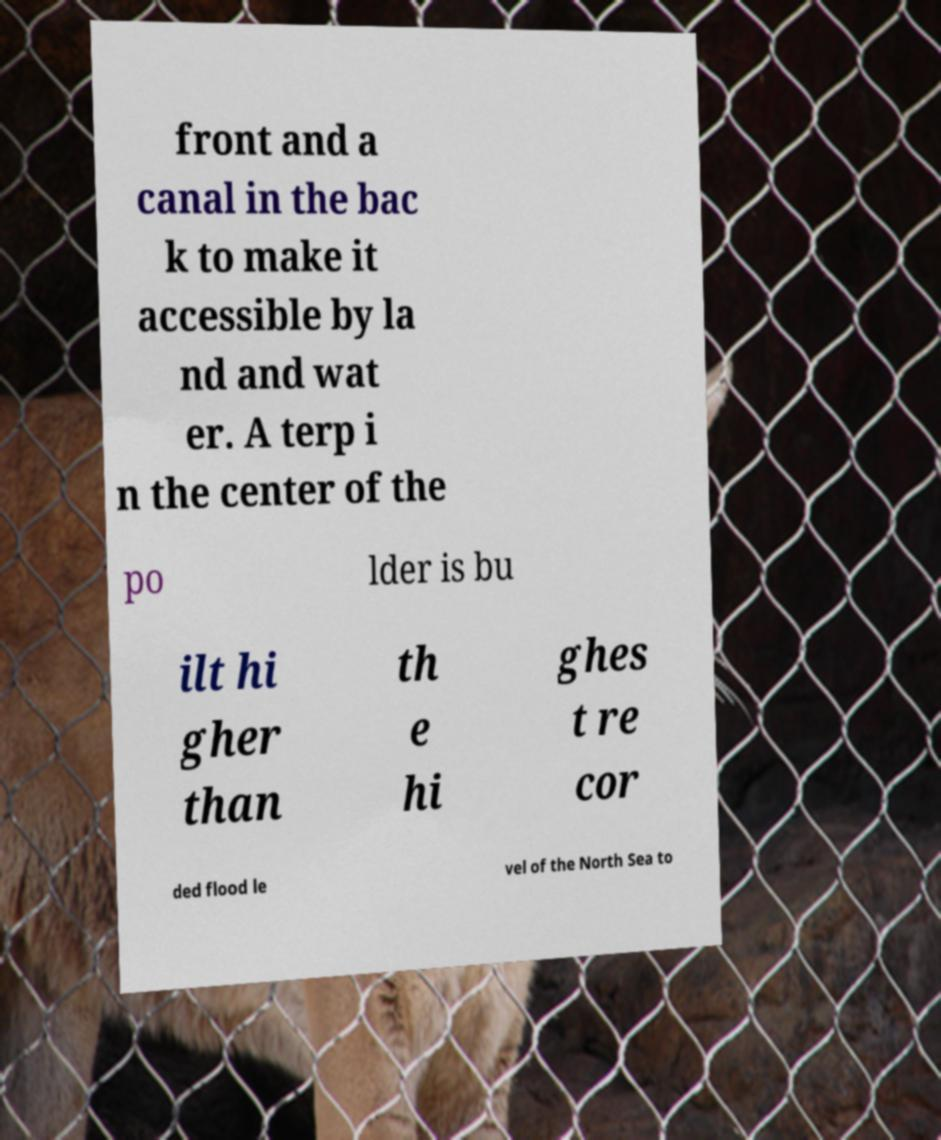Please identify and transcribe the text found in this image. front and a canal in the bac k to make it accessible by la nd and wat er. A terp i n the center of the po lder is bu ilt hi gher than th e hi ghes t re cor ded flood le vel of the North Sea to 